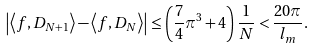<formula> <loc_0><loc_0><loc_500><loc_500>\left | \left \langle f , D _ { N + 1 } \right \rangle - \left \langle f , D _ { N } \right \rangle \right | \leq \left ( \frac { 7 } { 4 } \pi ^ { 3 } + 4 \right ) \frac { 1 } { N } < \frac { 2 0 \pi } { l _ { m } } .</formula> 